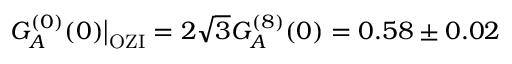<formula> <loc_0><loc_0><loc_500><loc_500>G _ { A } ^ { ( 0 ) } ( 0 ) \Big | _ { O Z I } = 2 \sqrt { 3 } G _ { A } ^ { ( 8 ) } ( 0 ) = 0 . 5 8 \pm 0 . 0 2</formula> 